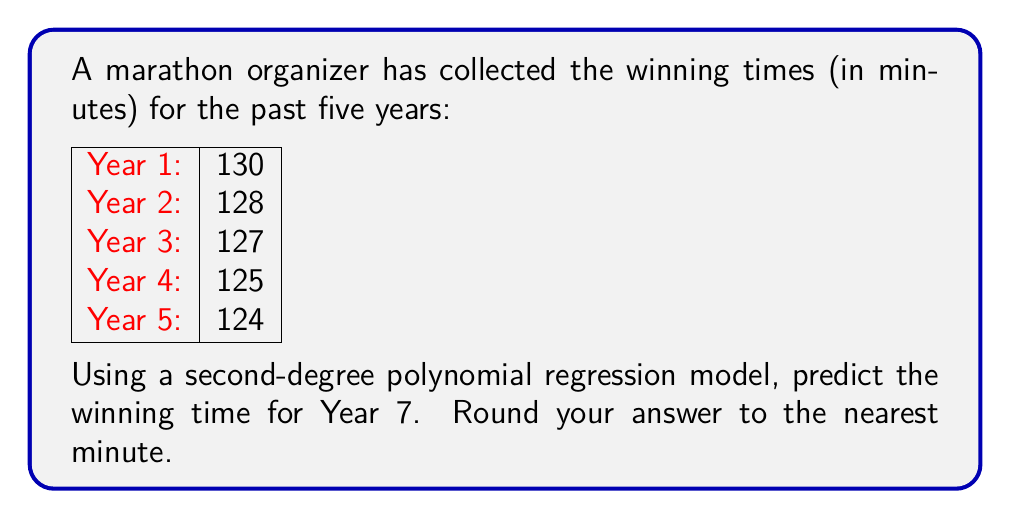Could you help me with this problem? To predict the winning time for Year 7 using a second-degree polynomial regression model, we'll follow these steps:

1) Let's define our polynomial as $y = ax^2 + bx + c$, where $y$ is the winning time and $x$ is the year number.

2) We need to solve for $a$, $b$, and $c$ using the given data points. We can use a system of equations:

   $130 = a(1)^2 + b(1) + c$
   $128 = a(2)^2 + b(2) + c$
   $127 = a(3)^2 + b(3) + c$
   $125 = a(4)^2 + b(4) + c$
   $124 = a(5)^2 + b(5) + c$

3) Solving this system (using a calculator or computer algebra system) gives us:

   $a = 0.5$
   $b = -4.5$
   $c = 134$

4) So our polynomial is: $y = 0.5x^2 - 4.5x + 134$

5) To predict Year 7, we substitute $x = 7$ into our equation:

   $y = 0.5(7)^2 - 4.5(7) + 134$
   $y = 0.5(49) - 31.5 + 134$
   $y = 24.5 - 31.5 + 134$
   $y = 127$

6) Rounding to the nearest minute, our prediction for Year 7 is 127 minutes.
Answer: 127 minutes 